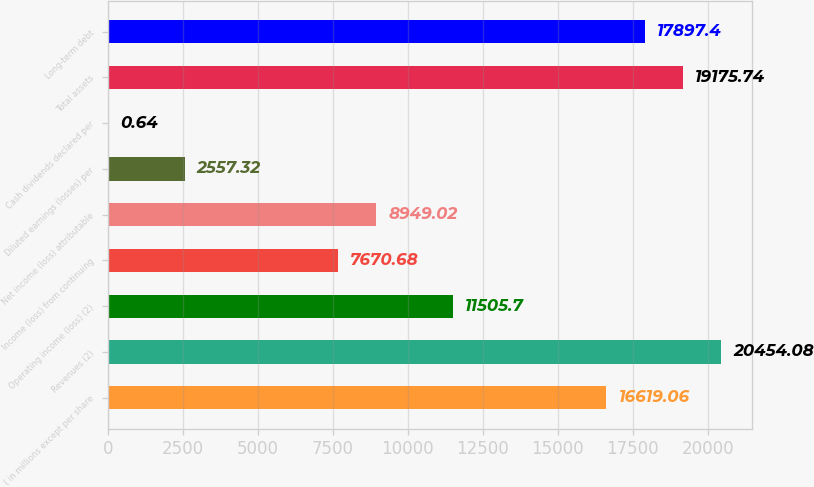Convert chart to OTSL. <chart><loc_0><loc_0><loc_500><loc_500><bar_chart><fcel>( in millions except per share<fcel>Revenues (2)<fcel>Operating income (loss) (2)<fcel>Income (loss) from continuing<fcel>Net income (loss) attributable<fcel>Diluted earnings (losses) per<fcel>Cash dividends declared per<fcel>Total assets<fcel>Long-term debt<nl><fcel>16619.1<fcel>20454.1<fcel>11505.7<fcel>7670.68<fcel>8949.02<fcel>2557.32<fcel>0.64<fcel>19175.7<fcel>17897.4<nl></chart> 